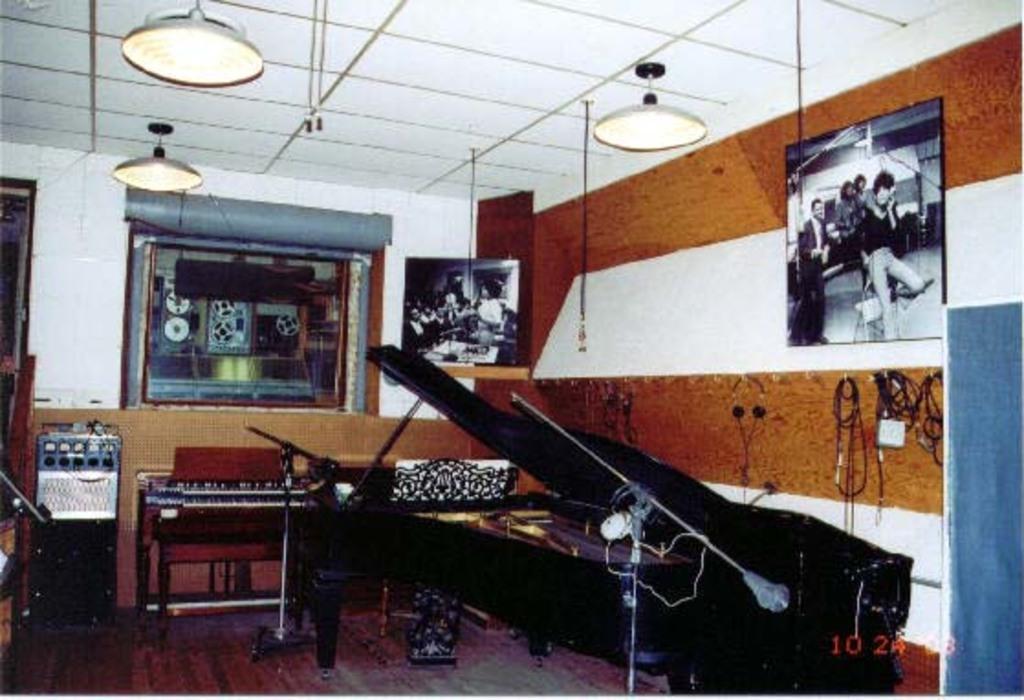Please provide a concise description of this image. In this image i can see few musical instruments at right there is a frame attached to a wall, in the frame there are few persons standing, wearing a blazer at the back ground can see a recorder, at the top there are few lights. 